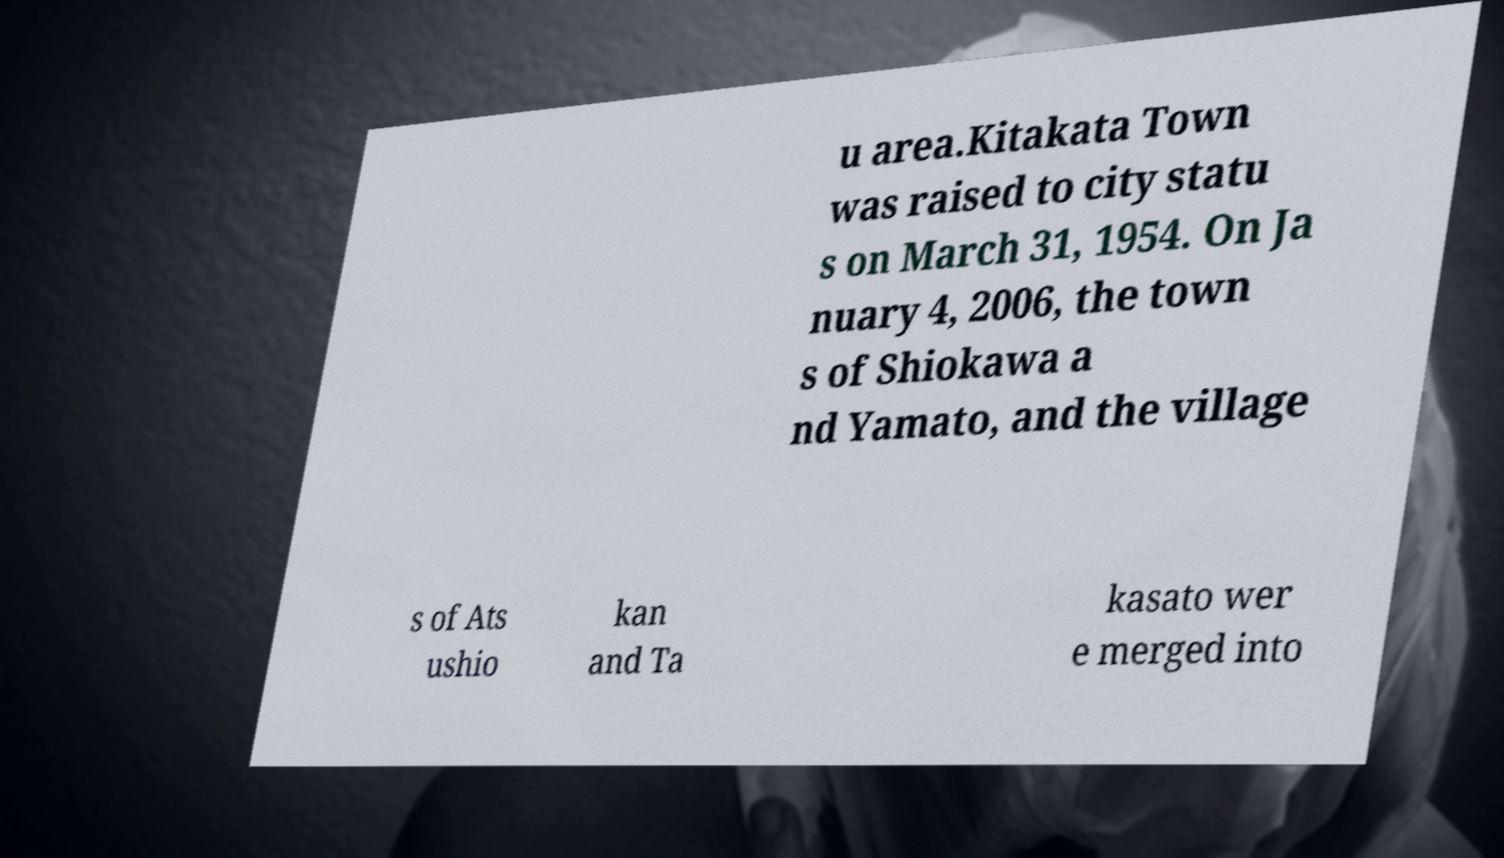Can you accurately transcribe the text from the provided image for me? u area.Kitakata Town was raised to city statu s on March 31, 1954. On Ja nuary 4, 2006, the town s of Shiokawa a nd Yamato, and the village s of Ats ushio kan and Ta kasato wer e merged into 